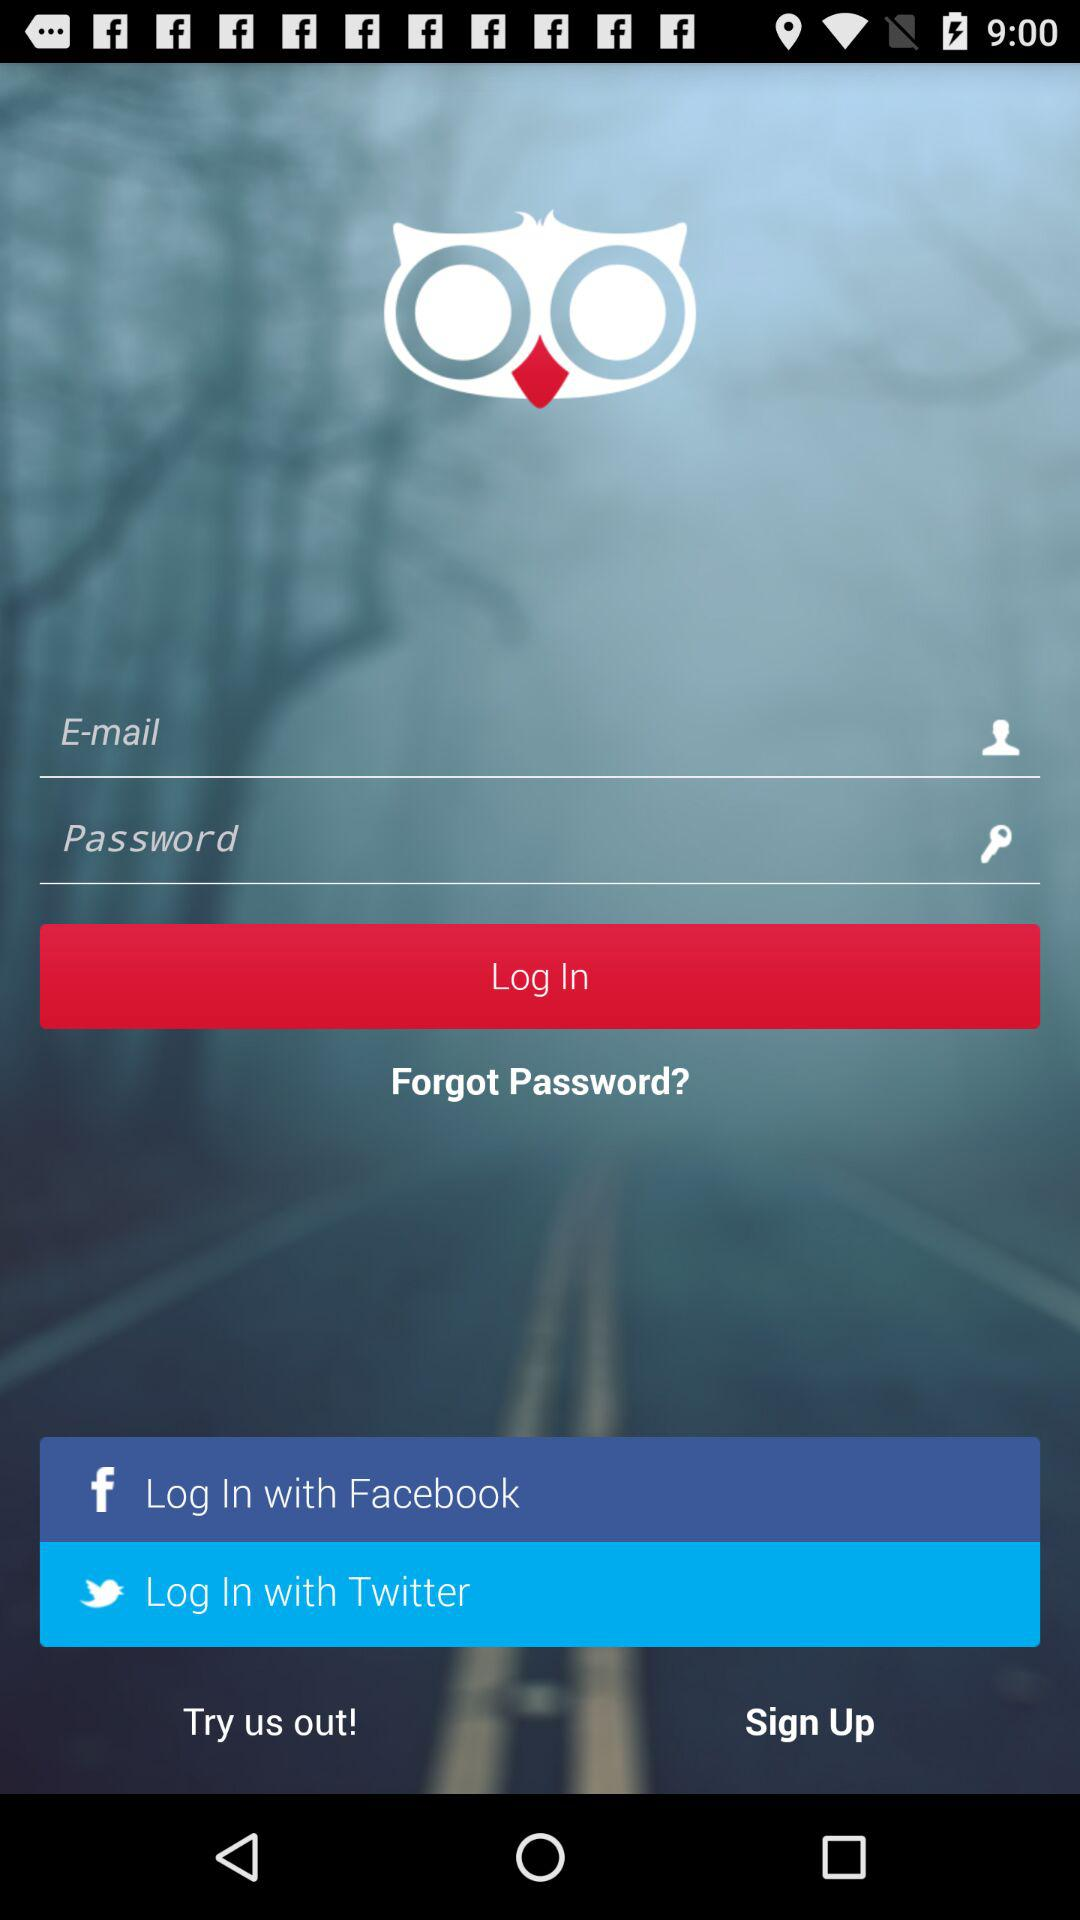How many social media login options are there?
Answer the question using a single word or phrase. 2 